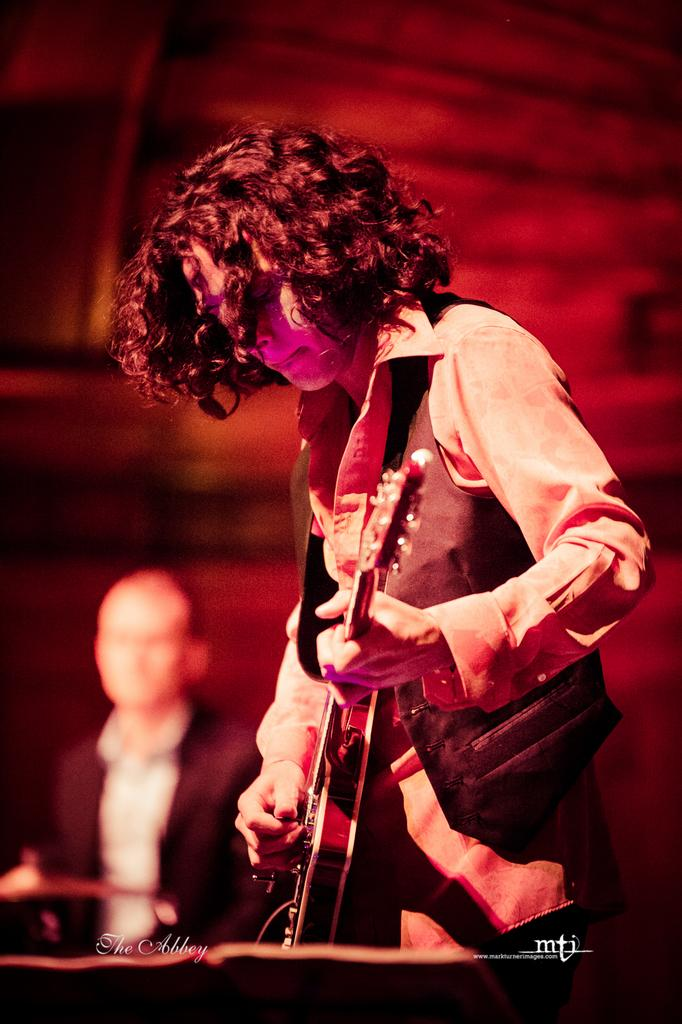What is the main activity being performed by the person in the image? The person in the image is playing a guitar. Can you describe the setting of the image? There is another person seated in the background of the image. What type of ear is visible on the guitar in the image? There is no ear visible on the guitar in the image, as guitars do not have ears. 